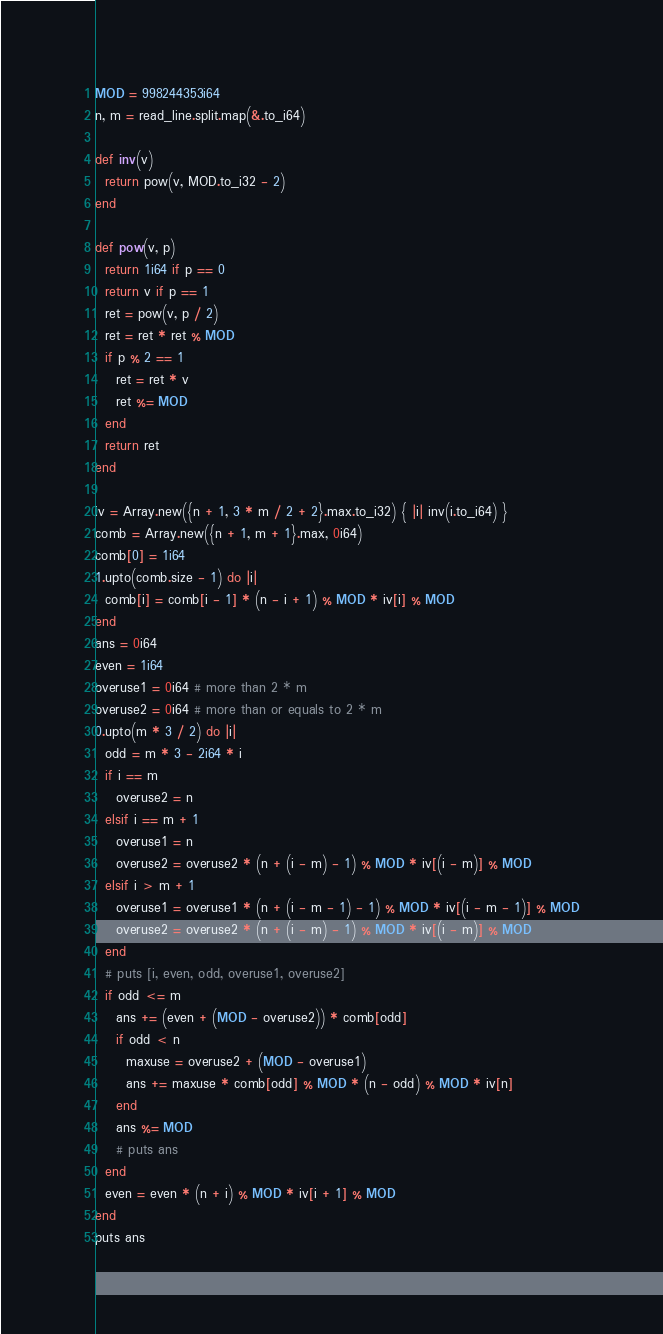<code> <loc_0><loc_0><loc_500><loc_500><_Crystal_>MOD = 998244353i64
n, m = read_line.split.map(&.to_i64)

def inv(v)
  return pow(v, MOD.to_i32 - 2)
end

def pow(v, p)
  return 1i64 if p == 0
  return v if p == 1
  ret = pow(v, p / 2)
  ret = ret * ret % MOD
  if p % 2 == 1
    ret = ret * v
    ret %= MOD
  end
  return ret
end

iv = Array.new({n + 1, 3 * m / 2 + 2}.max.to_i32) { |i| inv(i.to_i64) }
comb = Array.new({n + 1, m + 1}.max, 0i64)
comb[0] = 1i64
1.upto(comb.size - 1) do |i|
  comb[i] = comb[i - 1] * (n - i + 1) % MOD * iv[i] % MOD
end
ans = 0i64
even = 1i64
overuse1 = 0i64 # more than 2 * m
overuse2 = 0i64 # more than or equals to 2 * m
0.upto(m * 3 / 2) do |i|
  odd = m * 3 - 2i64 * i
  if i == m
    overuse2 = n
  elsif i == m + 1
    overuse1 = n
    overuse2 = overuse2 * (n + (i - m) - 1) % MOD * iv[(i - m)] % MOD
  elsif i > m + 1
    overuse1 = overuse1 * (n + (i - m - 1) - 1) % MOD * iv[(i - m - 1)] % MOD
    overuse2 = overuse2 * (n + (i - m) - 1) % MOD * iv[(i - m)] % MOD
  end
  # puts [i, even, odd, overuse1, overuse2]
  if odd <= m
    ans += (even + (MOD - overuse2)) * comb[odd]
    if odd < n
      maxuse = overuse2 + (MOD - overuse1)
      ans += maxuse * comb[odd] % MOD * (n - odd) % MOD * iv[n]
    end
    ans %= MOD
    # puts ans
  end
  even = even * (n + i) % MOD * iv[i + 1] % MOD
end
puts ans
</code> 